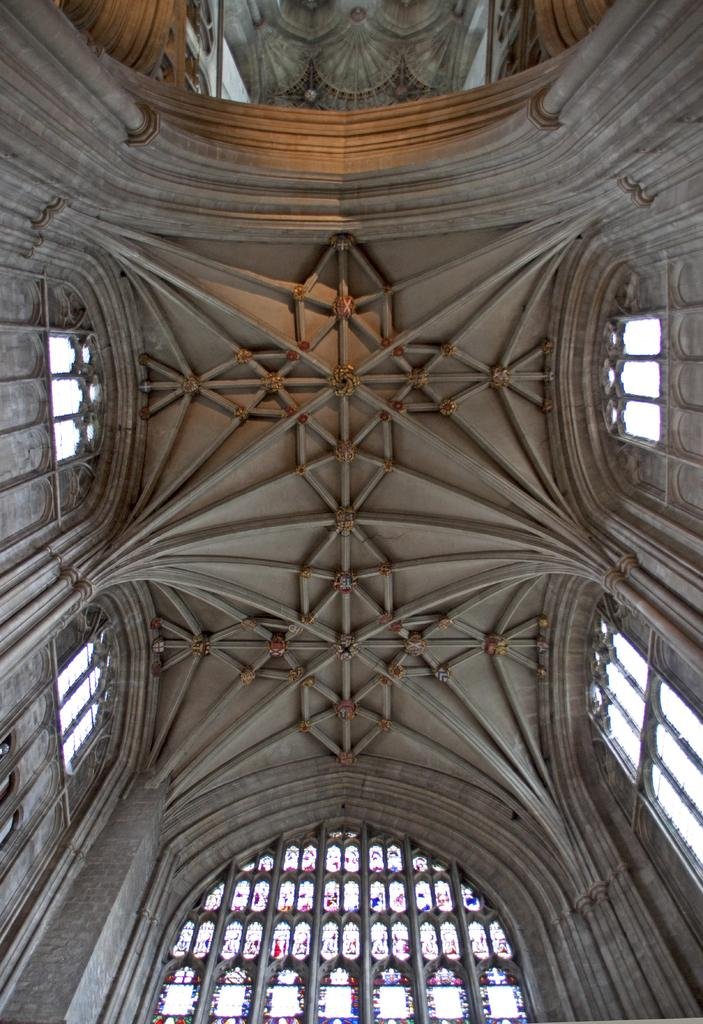What is the design of the roof in the image? There is a designed roof in the image. What can be seen on the walls of the structure in the image? There are windows in the image. What objects are visible on a surface in the image? There are glasses in the image. Where is the hall located in the image? There is no hall present in the image. What type of flower can be seen growing near the windows in the image? There are no flowers present in the image. Can you tell me how the tramp is used in the image? There is no tramp present in the image. 